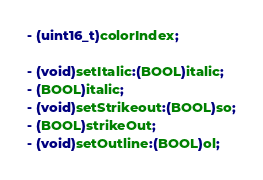<code> <loc_0><loc_0><loc_500><loc_500><_C_>- (uint16_t)colorIndex;

- (void)setItalic:(BOOL)italic;
- (BOOL)italic;
- (void)setStrikeout:(BOOL)so;
- (BOOL)strikeOut;
- (void)setOutline:(BOOL)ol;</code> 